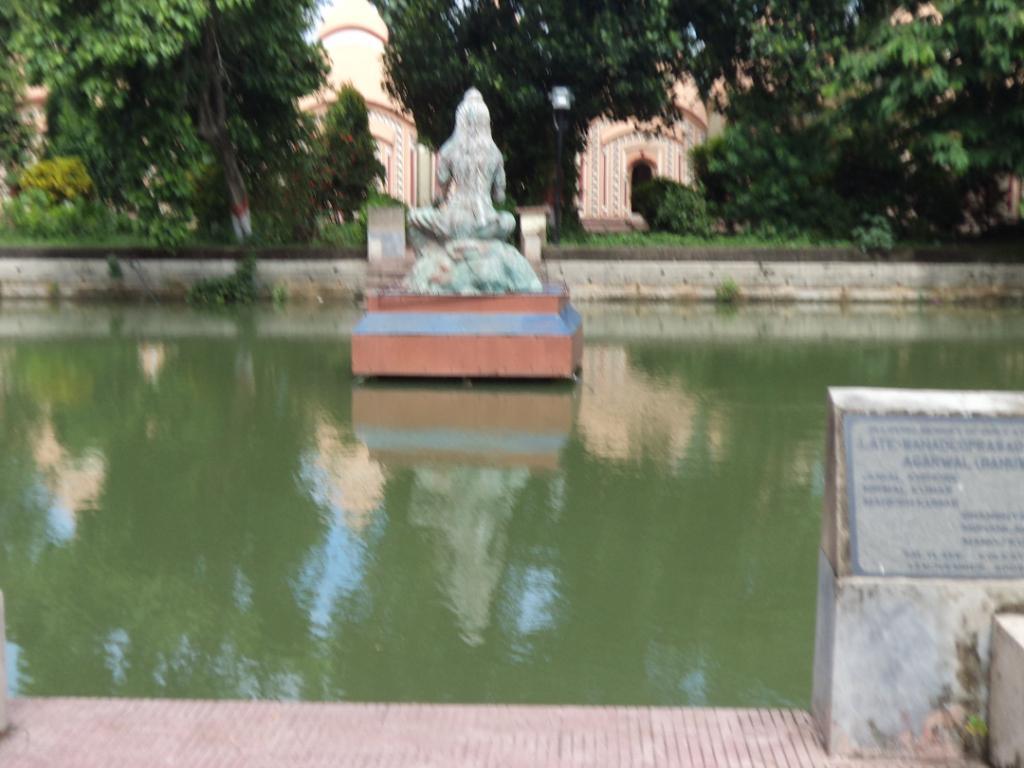How would you summarize this image in a sentence or two? In this image I can see water and in the centre I can see a sculpture on the water. In the background I can see number of trees, few buildings and on the right side I can see something is written on the stone board. 